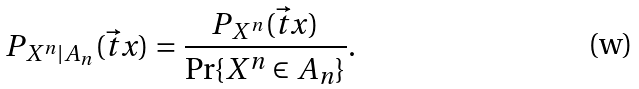Convert formula to latex. <formula><loc_0><loc_0><loc_500><loc_500>P _ { X ^ { n } | A _ { n } } ( \vec { t } { x } ) = \frac { P _ { X ^ { n } } ( \vec { t } { x } ) } { \Pr \{ X ^ { n } \in A _ { n } \} } .</formula> 